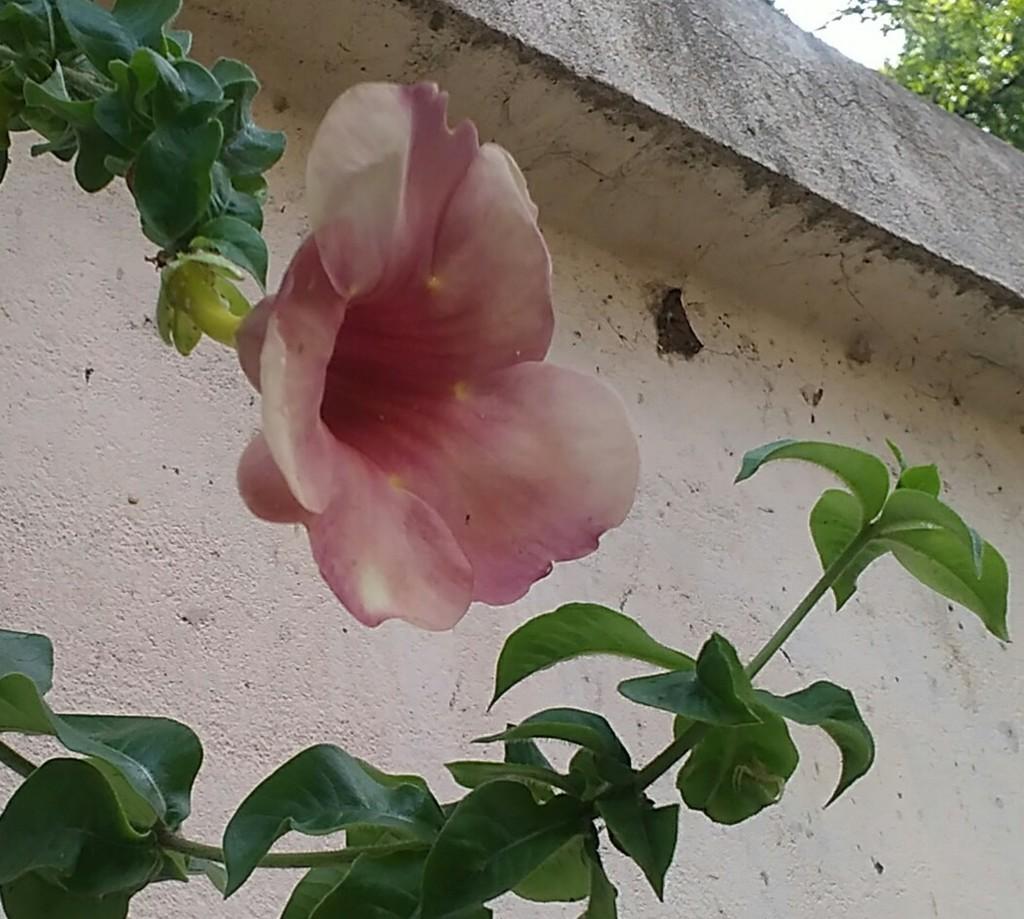In one or two sentences, can you explain what this image depicts? In this picture we can see a flower, plants and a wall, in the background we can find a tree. 